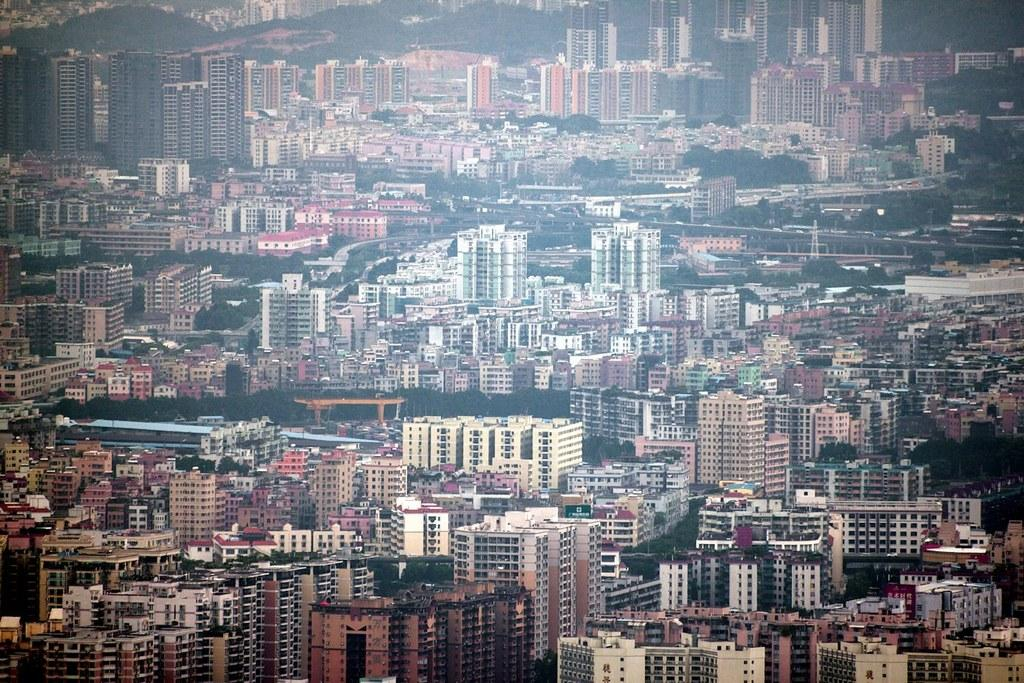What type of location is depicted in the image? The image depicts a well-developed city. What are some of the prominent features of the city? There are numerous towers and many buildings in the city. Are there any natural elements present in the city? Yes, there are trees present between some of the buildings. What type of teaching is taking place in the image? There is no teaching activity depicted in the image; it shows a cityscape with towers, buildings, and trees. 